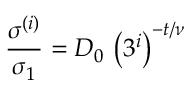Convert formula to latex. <formula><loc_0><loc_0><loc_500><loc_500>\frac { \sigma ^ { ( i ) } } { \sigma _ { 1 } } = D _ { 0 } \, \left ( 3 ^ { i } \right ) ^ { - t / \nu }</formula> 